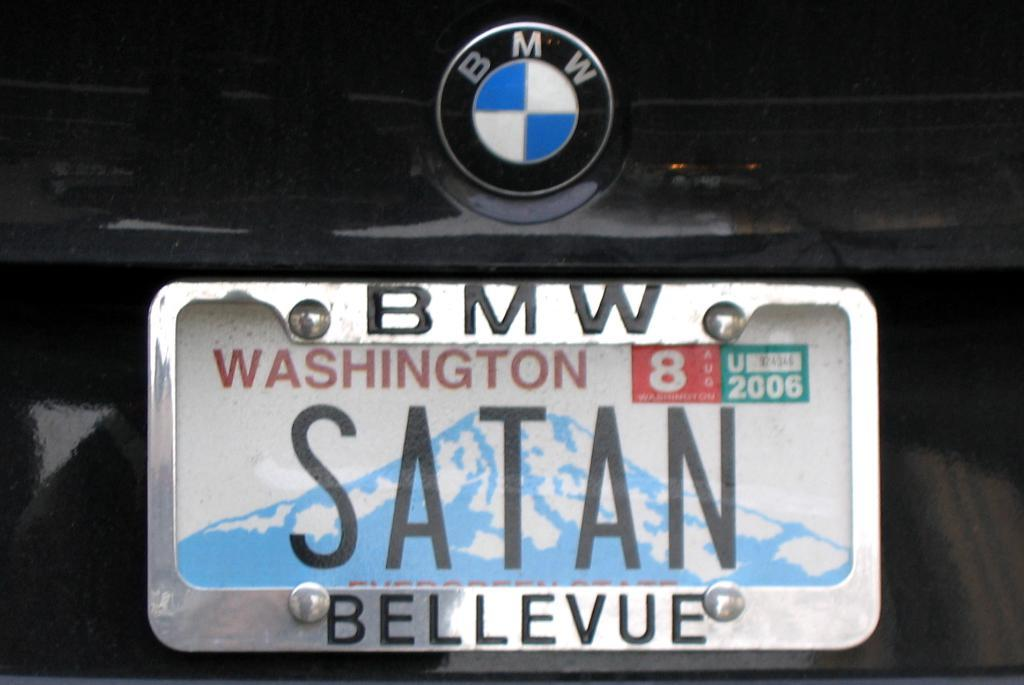<image>
Create a compact narrative representing the image presented. A bmw branded sedan has the washington state license plate with the text satan on it. 